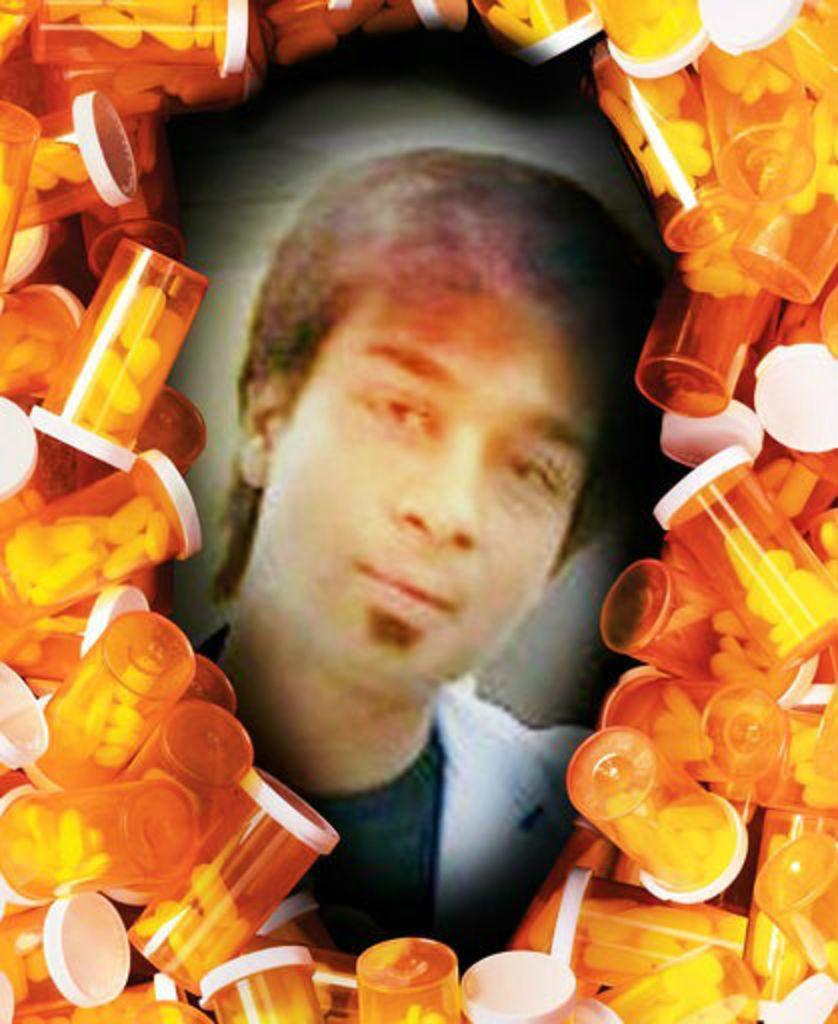What is the main subject of the image? The main subject of the image is a person's photo. What else can be seen in the image besides the person's photo? There are many bottles and pills visible in the image. How many chairs are visible in the image? There are no chairs visible in the image. What type of basin is present in the image? There is no basin present in the image. 